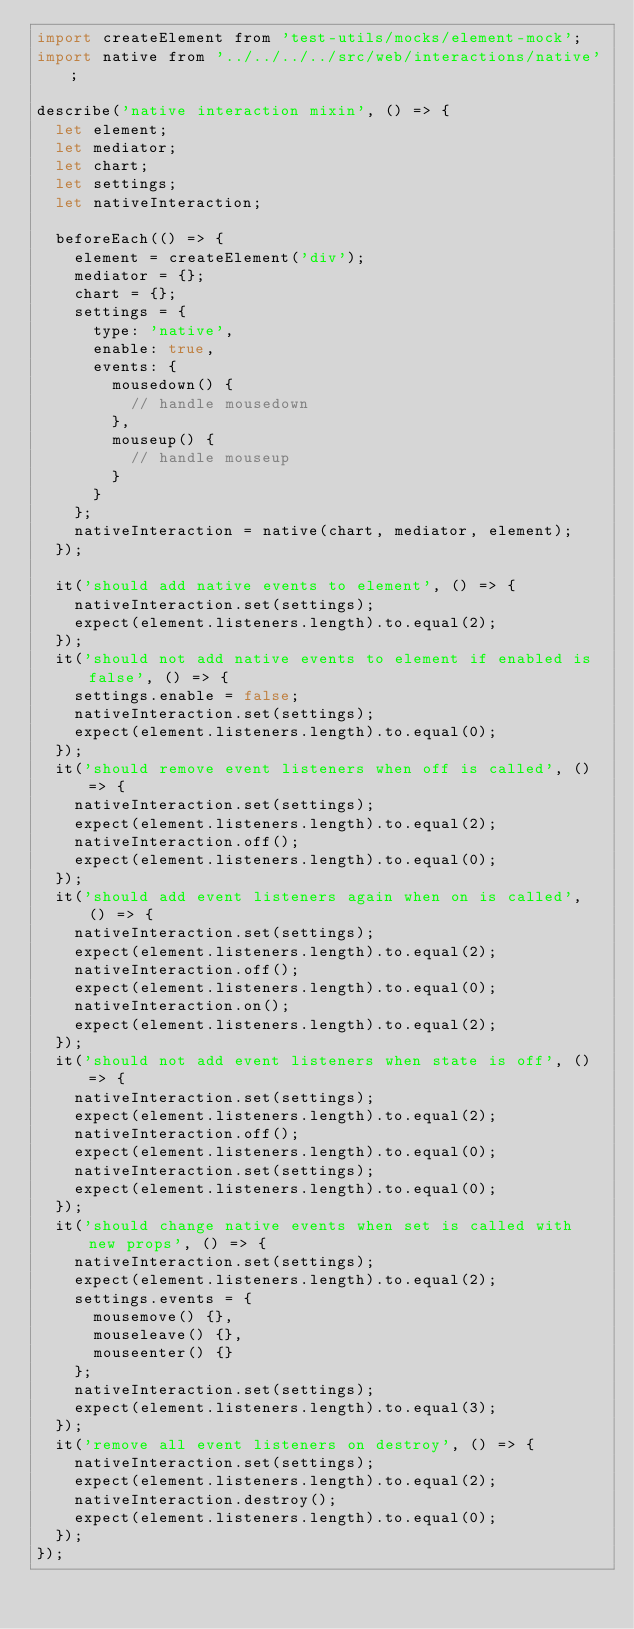Convert code to text. <code><loc_0><loc_0><loc_500><loc_500><_JavaScript_>import createElement from 'test-utils/mocks/element-mock';
import native from '../../../../src/web/interactions/native';

describe('native interaction mixin', () => {
  let element;
  let mediator;
  let chart;
  let settings;
  let nativeInteraction;

  beforeEach(() => {
    element = createElement('div');
    mediator = {};
    chart = {};
    settings = {
      type: 'native',
      enable: true,
      events: {
        mousedown() {
          // handle mousedown
        },
        mouseup() {
          // handle mouseup
        }
      }
    };
    nativeInteraction = native(chart, mediator, element);
  });

  it('should add native events to element', () => {
    nativeInteraction.set(settings);
    expect(element.listeners.length).to.equal(2);
  });
  it('should not add native events to element if enabled is false', () => {
    settings.enable = false;
    nativeInteraction.set(settings);
    expect(element.listeners.length).to.equal(0);
  });
  it('should remove event listeners when off is called', () => {
    nativeInteraction.set(settings);
    expect(element.listeners.length).to.equal(2);
    nativeInteraction.off();
    expect(element.listeners.length).to.equal(0);
  });
  it('should add event listeners again when on is called', () => {
    nativeInteraction.set(settings);
    expect(element.listeners.length).to.equal(2);
    nativeInteraction.off();
    expect(element.listeners.length).to.equal(0);
    nativeInteraction.on();
    expect(element.listeners.length).to.equal(2);
  });
  it('should not add event listeners when state is off', () => {
    nativeInteraction.set(settings);
    expect(element.listeners.length).to.equal(2);
    nativeInteraction.off();
    expect(element.listeners.length).to.equal(0);
    nativeInteraction.set(settings);
    expect(element.listeners.length).to.equal(0);
  });
  it('should change native events when set is called with new props', () => {
    nativeInteraction.set(settings);
    expect(element.listeners.length).to.equal(2);
    settings.events = {
      mousemove() {},
      mouseleave() {},
      mouseenter() {}
    };
    nativeInteraction.set(settings);
    expect(element.listeners.length).to.equal(3);
  });
  it('remove all event listeners on destroy', () => {
    nativeInteraction.set(settings);
    expect(element.listeners.length).to.equal(2);
    nativeInteraction.destroy();
    expect(element.listeners.length).to.equal(0);
  });
});
</code> 